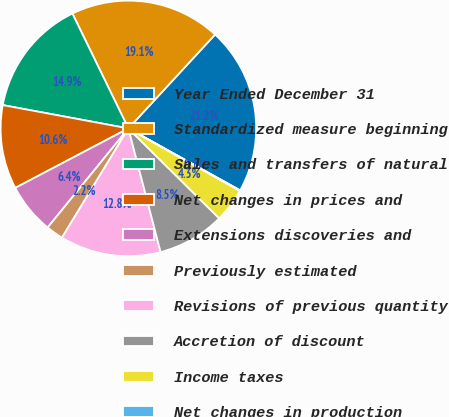Convert chart to OTSL. <chart><loc_0><loc_0><loc_500><loc_500><pie_chart><fcel>Year Ended December 31<fcel>Standardized measure beginning<fcel>Sales and transfers of natural<fcel>Net changes in prices and<fcel>Extensions discoveries and<fcel>Previously estimated<fcel>Revisions of previous quantity<fcel>Accretion of discount<fcel>Income taxes<fcel>Net changes in production<nl><fcel>21.19%<fcel>19.08%<fcel>14.86%<fcel>10.63%<fcel>6.41%<fcel>2.19%<fcel>12.75%<fcel>8.52%<fcel>4.3%<fcel>0.07%<nl></chart> 